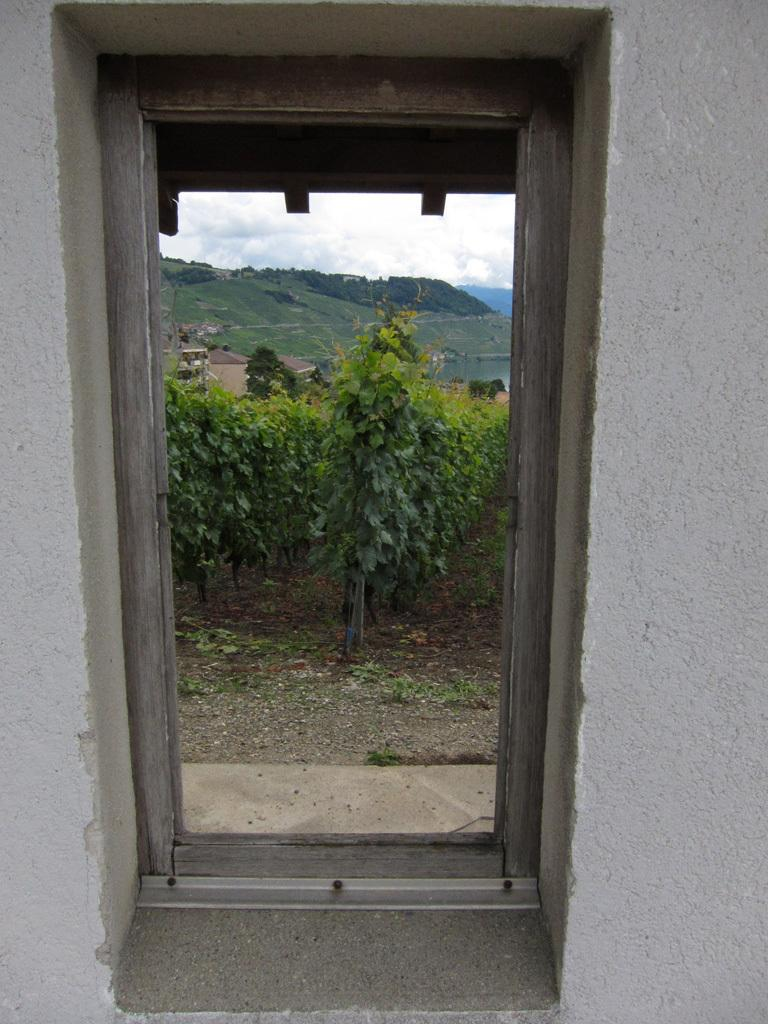What is located in the center of the image? There is a door in the center of the image. What can be seen in the background of the image? Mountains and plants are visible in the background of the image. What surrounds the door on both sides? There are walls on both sides of the image. What type of fiction is being read by the bushes in the image? There are no bushes or any form of reading material present in the image. 